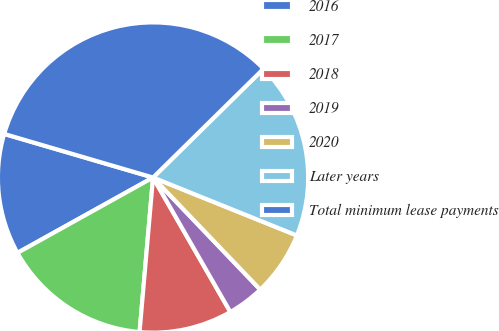<chart> <loc_0><loc_0><loc_500><loc_500><pie_chart><fcel>2016<fcel>2017<fcel>2018<fcel>2019<fcel>2020<fcel>Later years<fcel>Total minimum lease payments<nl><fcel>12.61%<fcel>15.54%<fcel>9.69%<fcel>3.84%<fcel>6.76%<fcel>18.47%<fcel>33.09%<nl></chart> 